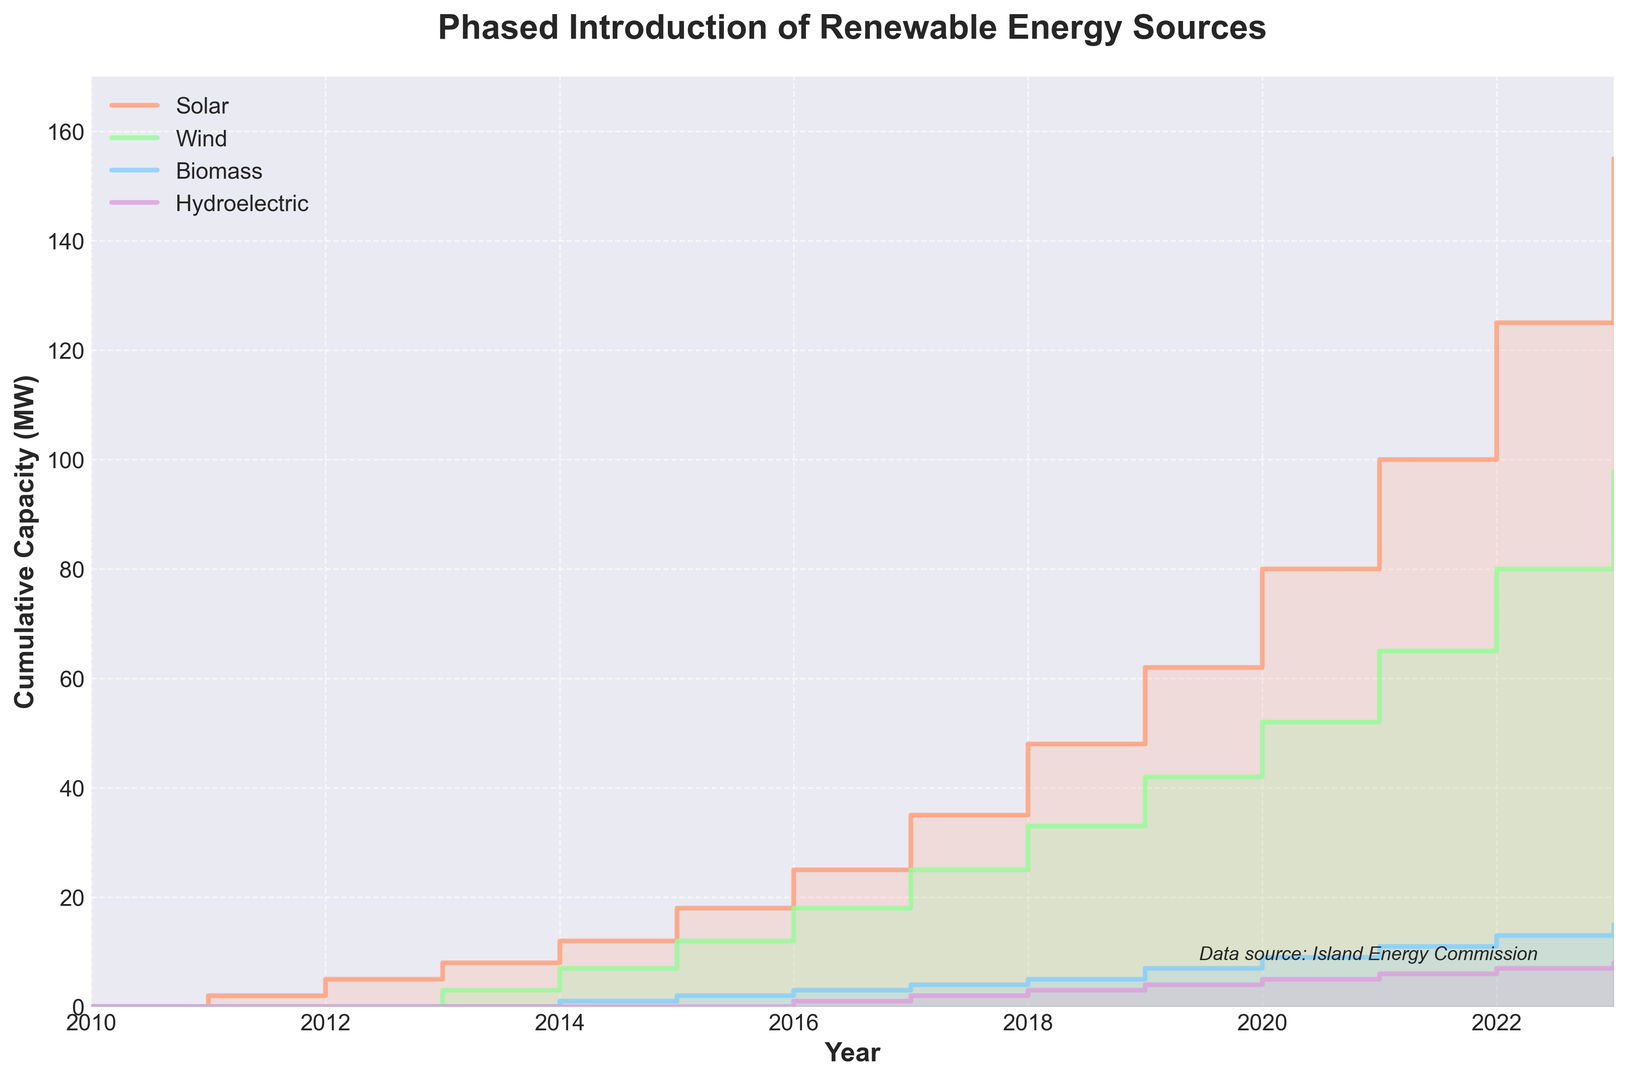What is the total cumulative capacity of renewable energy sources in 2023? To find the total cumulative capacity, sum the capacities of Solar, Wind, Biomass, and Hydroelectric for the year 2023. 155 (Solar) + 98 (Wind) + 15 (Biomass) + 8 (Hydroelectric) = 276 MW
Answer: 276 MW Which renewable energy source saw the highest increase in cumulative capacity between 2019 and 2020? Check the increase in capacity for each source between 2019 and 2020. Solar increased by 18 MW (80 - 62), Wind increased by 10 MW (52 - 42), Biomass increased by 2 MW (9 - 7), and Hydroelectric increased by 1 MW (5 - 4). Solar has the highest increase of 18 MW
Answer: Solar What is the difference in cumulative capacity between Solar and Wind in 2022? Subtract Wind capacity from Solar capacity for the year 2022. 125 (Solar) - 80 (Wind) = 45 MW
Answer: 45 MW How has the cumulative capacity of Biomass changed from 2014 to 2021? Subtract the Biomass capacity in 2014 from the capacity in 2021. 11 (2021) - 1 (2014) = 10 MW
Answer: 10 MW In which year did Hydroelectric reach a cumulative capacity of 2 MW? Identify the year on the x-axis where the Hydroelectric capacity line reaches the value 2 MW. According to the plot, it's in 2017.
Answer: 2017 By how much did the total cumulative capacity increase from 2010 to 2015? Find the total cumulative capacity for 2015 and subtract the total cumulative capacity in 2010. 18 (Solar) + 12 (Wind) + 2 (Biomass) + 0 (Hydroelectric) = 32 MW (2015 total); 0 MW (2010 total), so 32 MW - 0 MW = 32 MW
Answer: 32 MW Which renewable energy source had the lowest cumulative capacity increase from 2010 to 2023? Compare the cumulative capacities in 2010 and 2023 for each source. Hydroelectric increased by 8 MW (8 - 0), Biomass increased by 15 MW (15 - 0), Wind increased by 98 MW (98 - 0), and Solar increased by 155 MW (155 - 0). Hydroelectric has the lowest increase of 8 MW
Answer: Hydroelectric What is the cumulative capacity of Wind energy in 2020, and how does it compare to Solar energy in the same year? Look at the capacities in 2020 and compare them. Wind is 52 MW and Solar is 80 MW. Solar capacity is higher by 80 - 52 = 28 MW
Answer: Wind: 52 MW, Solar higher by 28 MW Between which consecutive years did Solar energy see the highest increase in cumulative capacity? Compare the differences in Solar capacities between consecutive years. The highest increase is from 2019 (62 MW) to 2020 (80 MW), which is an increase of 18 MW.
Answer: 2019 to 2020 How many years did it take for Biomass to reach a cumulative capacity of 10 MW after its introduction? Biomass first appears in the data in 2014 with 1 MW. It reaches or surpasses 10 MW in 2021 with 11 MW. Count the years from 2014 to 2021: 2021 - 2014 = 7 years.
Answer: 7 years 